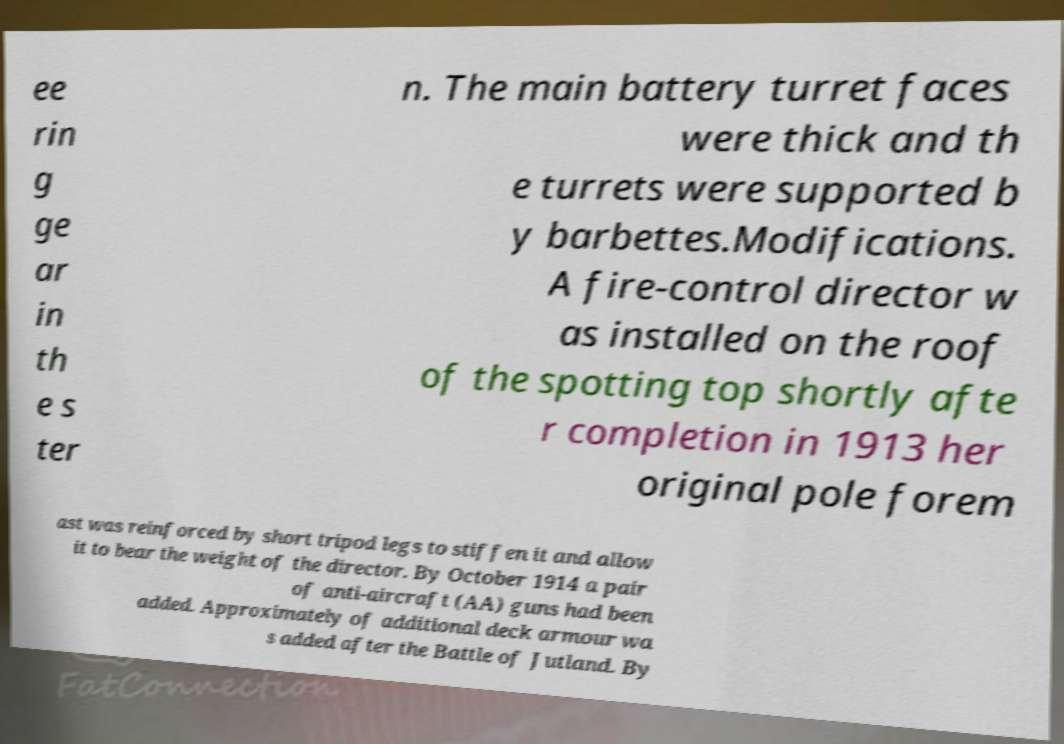What messages or text are displayed in this image? I need them in a readable, typed format. ee rin g ge ar in th e s ter n. The main battery turret faces were thick and th e turrets were supported b y barbettes.Modifications. A fire-control director w as installed on the roof of the spotting top shortly afte r completion in 1913 her original pole forem ast was reinforced by short tripod legs to stiffen it and allow it to bear the weight of the director. By October 1914 a pair of anti-aircraft (AA) guns had been added. Approximately of additional deck armour wa s added after the Battle of Jutland. By 